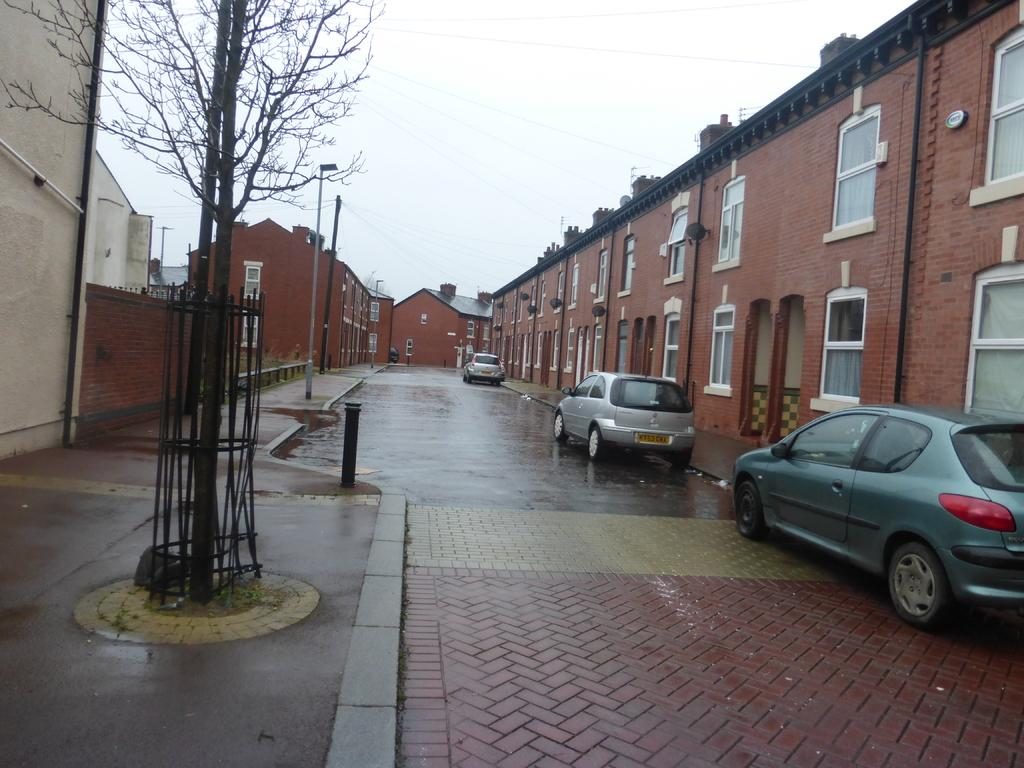What type of structures can be seen in the image? There are buildings in the image. What is happening on the road in the image? Motor vehicles are present on the road in the image. What are the vertical structures with signs or lights in the image? Street poles are visible in the image. What are the tall structures supporting electric cables in the image? Electric poles are present in the image. What are the cables connecting the electric poles in the image? Electric cables are visible in the image. What type of vegetation is present in the image? Trees are present in the image. What type of barrier can be seen in the image? Fences are visible in the image. What is visible in the background of the image? The sky is visible in the image. What can be seen in the sky in the image? Clouds are present in the sky. How many visitors are sitting on the wall in the image? There is no wall or visitors present in the image. What tool is the person using to fix the wrench in the image? There is no wrench or person using a tool present in the image. 